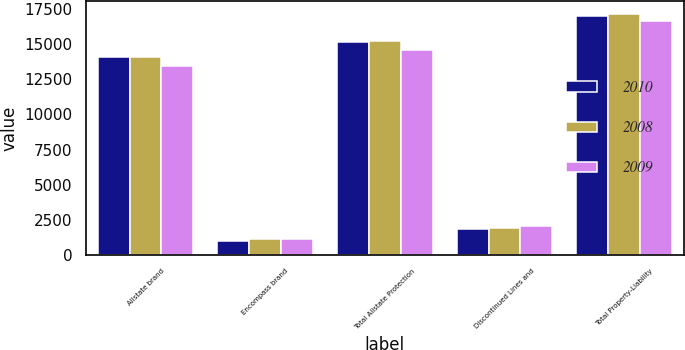Convert chart to OTSL. <chart><loc_0><loc_0><loc_500><loc_500><stacked_bar_chart><ecel><fcel>Allstate brand<fcel>Encompass brand<fcel>Total Allstate Protection<fcel>Discontinued Lines and<fcel>Total Property-Liability<nl><fcel>2010<fcel>14123<fcel>1027<fcel>15150<fcel>1878<fcel>17028<nl><fcel>2008<fcel>14118<fcel>1133<fcel>15251<fcel>1931<fcel>17182<nl><fcel>2009<fcel>13456<fcel>1129<fcel>14585<fcel>2075<fcel>16660<nl></chart> 